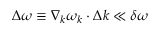Convert formula to latex. <formula><loc_0><loc_0><loc_500><loc_500>\Delta \omega \equiv \nabla _ { k } \omega _ { k } \cdot \Delta k \ll \delta \omega</formula> 